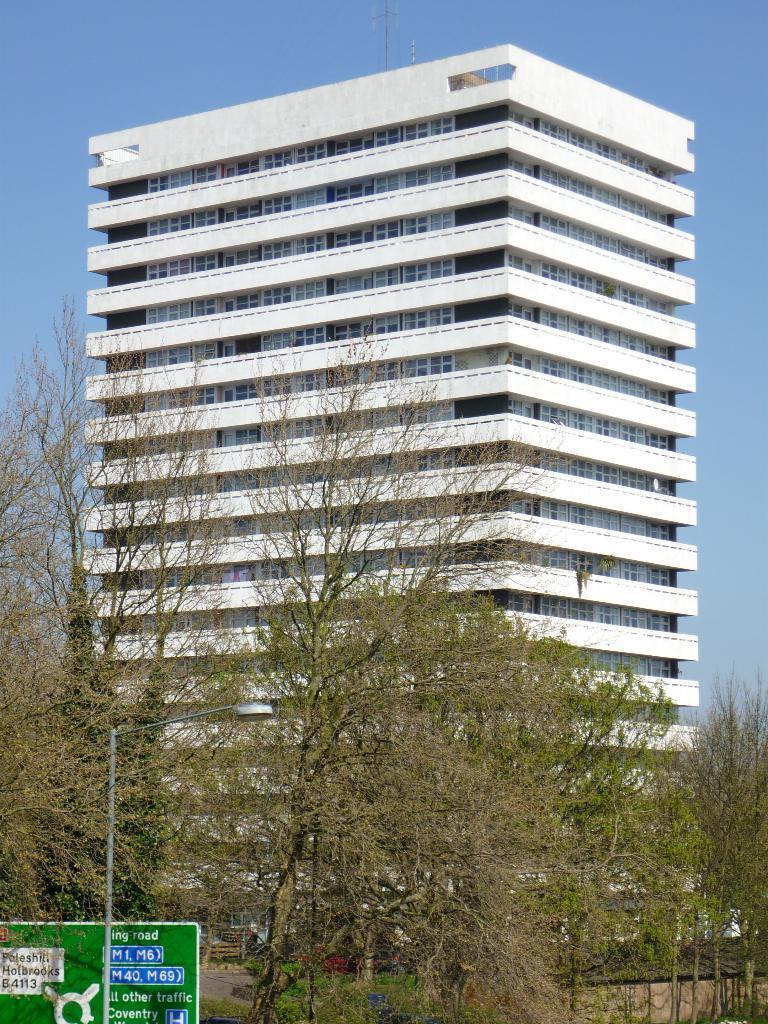Please provide a concise description of this image. In this picture I can see a building. There is a pole, light and a board. I can see trees, and in the background there is the sky. 